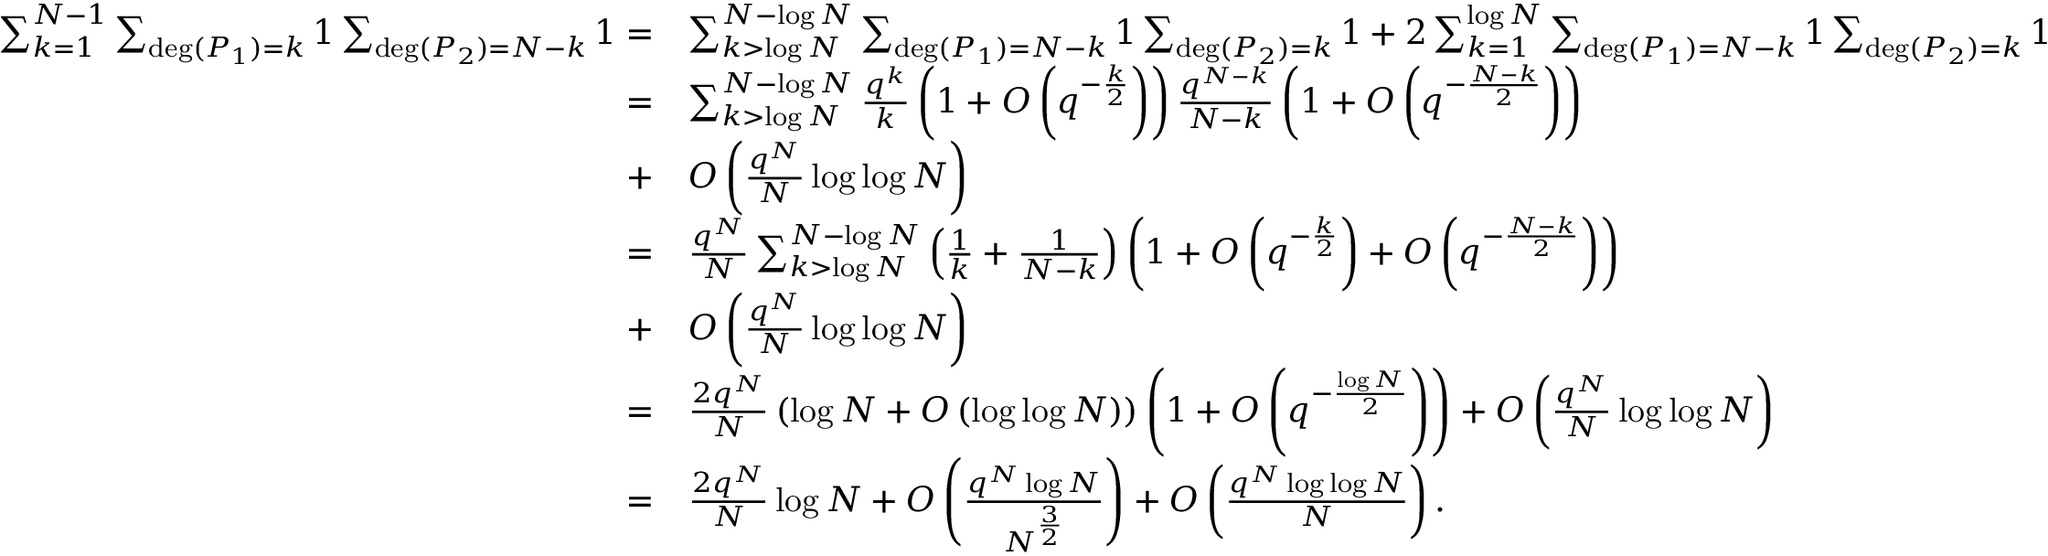<formula> <loc_0><loc_0><loc_500><loc_500>\begin{array} { r l } { \sum _ { k = 1 } ^ { N - 1 } \sum _ { \deg ( P _ { 1 } ) = k } 1 \sum _ { \deg ( P _ { 2 } ) = N - k } 1 = } & { \sum _ { k > \log N } ^ { N - \log N } \sum _ { \deg ( P _ { 1 } ) = N - k } 1 \sum _ { \deg ( P _ { 2 } ) = k } 1 + 2 \sum _ { k = 1 } ^ { \log N } \sum _ { \deg ( P _ { 1 } ) = N - k } 1 \sum _ { \deg ( P _ { 2 } ) = k } 1 } \\ { = } & { \sum _ { k > \log N } ^ { N - \log N } \frac { q ^ { k } } { k } \left ( 1 + O \left ( q ^ { - \frac { k } { 2 } } \right ) \right ) \frac { q ^ { N - k } } { N - k } \left ( 1 + O \left ( q ^ { - \frac { N - k } { 2 } } \right ) \right ) } \\ { + } & { O \left ( \frac { q ^ { N } } { N } \log \log N \right ) } \\ { = } & { \frac { q ^ { N } } { N } \sum _ { k > \log N } ^ { N - \log N } \left ( \frac { 1 } { k } + \frac { 1 } { N - k } \right ) \left ( 1 + O \left ( q ^ { - \frac { k } { 2 } } \right ) + O \left ( q ^ { - \frac { N - k } { 2 } } \right ) \right ) } \\ { + } & { O \left ( \frac { q ^ { N } } { N } \log \log N \right ) } \\ { = } & { \frac { 2 q ^ { N } } { N } \left ( \log N + O \left ( \log \log N \right ) \right ) \left ( 1 + O \left ( q ^ { - \frac { \log N } { 2 } } \right ) \right ) + O \left ( \frac { q ^ { N } } { N } \log \log N \right ) } \\ { = } & { \frac { 2 q ^ { N } } { N } \log N + O \left ( \frac { q ^ { N } \log N } { N ^ { \frac { 3 } { 2 } } } \right ) + O \left ( \frac { q ^ { N } \log \log N } { N } \right ) . } \end{array}</formula> 